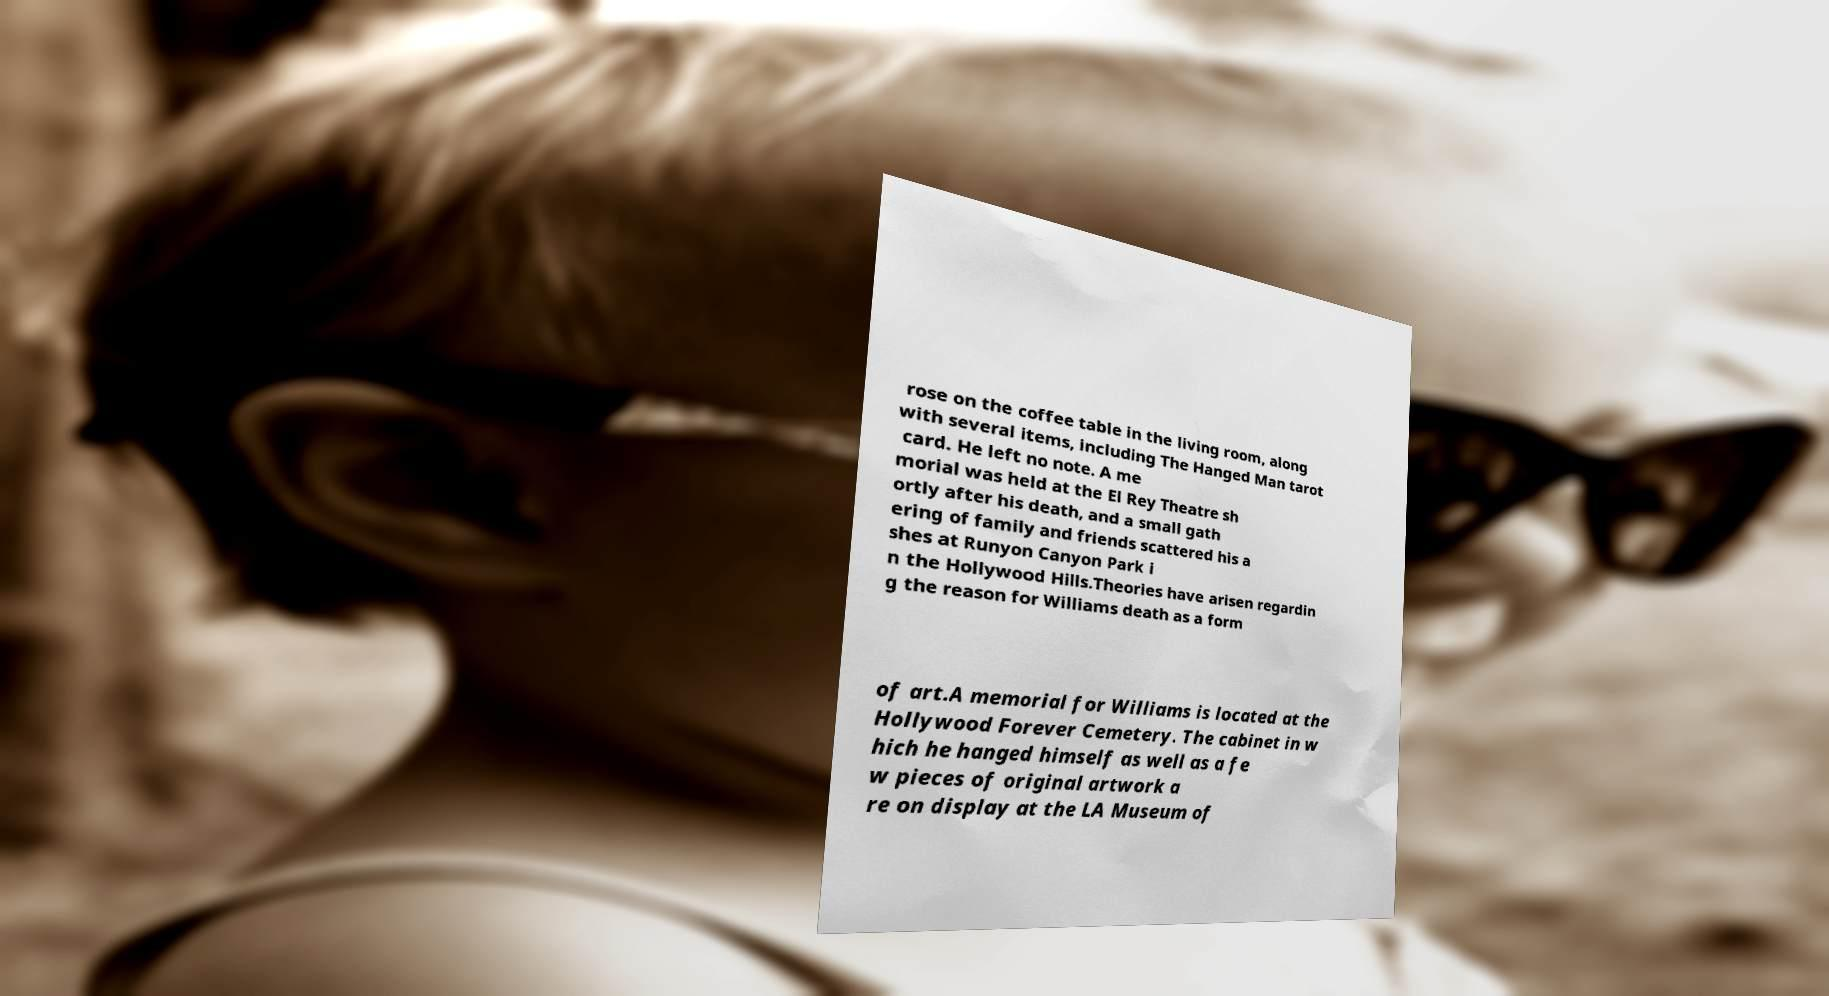Could you extract and type out the text from this image? rose on the coffee table in the living room, along with several items, including The Hanged Man tarot card. He left no note. A me morial was held at the El Rey Theatre sh ortly after his death, and a small gath ering of family and friends scattered his a shes at Runyon Canyon Park i n the Hollywood Hills.Theories have arisen regardin g the reason for Williams death as a form of art.A memorial for Williams is located at the Hollywood Forever Cemetery. The cabinet in w hich he hanged himself as well as a fe w pieces of original artwork a re on display at the LA Museum of 